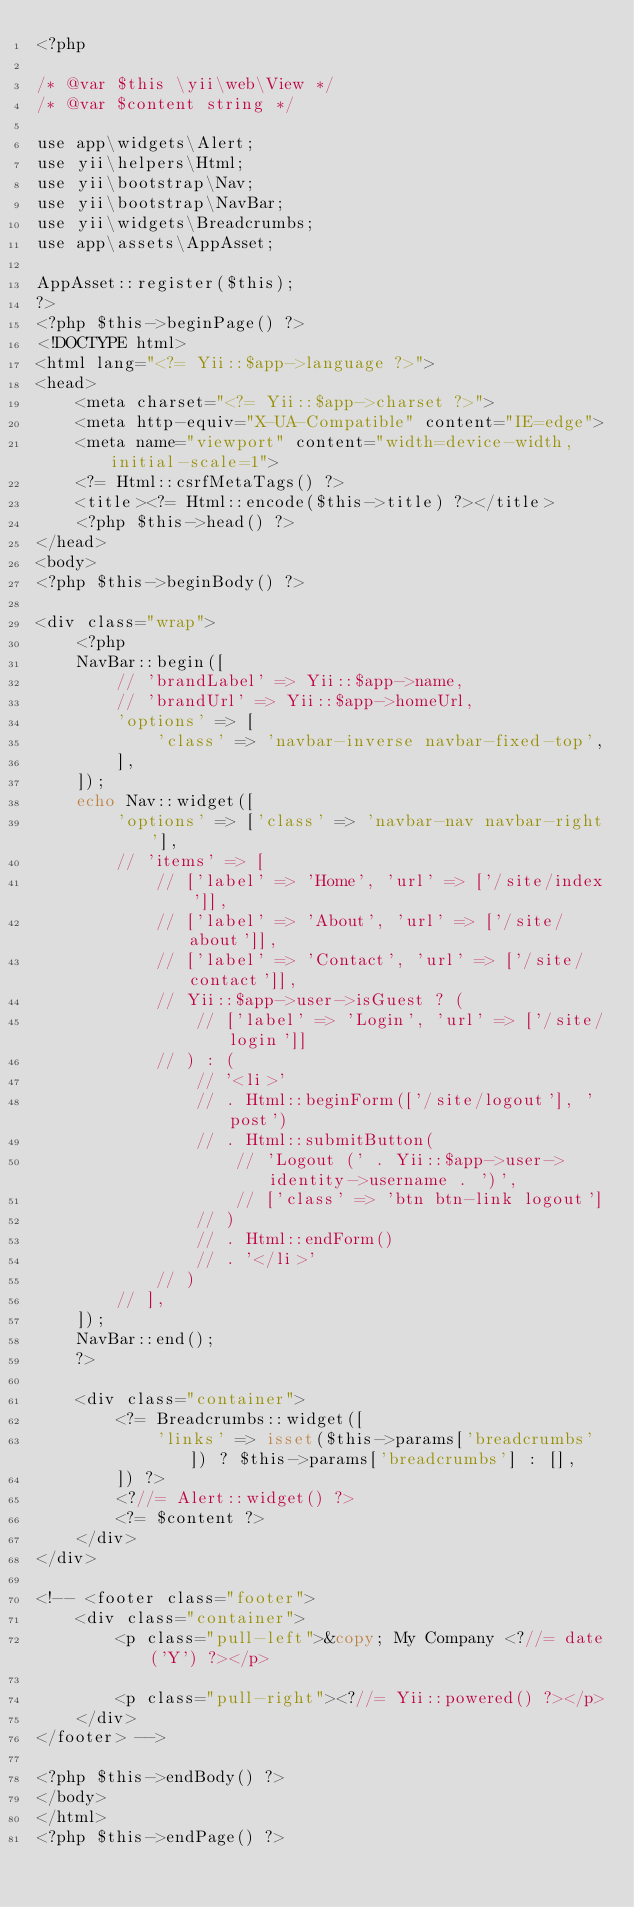Convert code to text. <code><loc_0><loc_0><loc_500><loc_500><_PHP_><?php

/* @var $this \yii\web\View */
/* @var $content string */

use app\widgets\Alert;
use yii\helpers\Html;
use yii\bootstrap\Nav;
use yii\bootstrap\NavBar;
use yii\widgets\Breadcrumbs;
use app\assets\AppAsset;

AppAsset::register($this);
?>
<?php $this->beginPage() ?>
<!DOCTYPE html>
<html lang="<?= Yii::$app->language ?>">
<head>
    <meta charset="<?= Yii::$app->charset ?>">
    <meta http-equiv="X-UA-Compatible" content="IE=edge">
    <meta name="viewport" content="width=device-width, initial-scale=1">
    <?= Html::csrfMetaTags() ?>
    <title><?= Html::encode($this->title) ?></title>
    <?php $this->head() ?>
</head>
<body>
<?php $this->beginBody() ?>

<div class="wrap">
    <?php
    NavBar::begin([
        // 'brandLabel' => Yii::$app->name,
        // 'brandUrl' => Yii::$app->homeUrl,
        'options' => [
            'class' => 'navbar-inverse navbar-fixed-top',
        ],
    ]);
    echo Nav::widget([
        'options' => ['class' => 'navbar-nav navbar-right'],
        // 'items' => [
            // ['label' => 'Home', 'url' => ['/site/index']],
            // ['label' => 'About', 'url' => ['/site/about']],
            // ['label' => 'Contact', 'url' => ['/site/contact']],
            // Yii::$app->user->isGuest ? (
                // ['label' => 'Login', 'url' => ['/site/login']]
            // ) : (
                // '<li>'
                // . Html::beginForm(['/site/logout'], 'post')
                // . Html::submitButton(
                    // 'Logout (' . Yii::$app->user->identity->username . ')',
                    // ['class' => 'btn btn-link logout']
                // )
                // . Html::endForm()
                // . '</li>'
            // )
        // ],
    ]);
    NavBar::end();
    ?>

    <div class="container">
        <?= Breadcrumbs::widget([
            'links' => isset($this->params['breadcrumbs']) ? $this->params['breadcrumbs'] : [],
        ]) ?>
        <?//= Alert::widget() ?>
        <?= $content ?>
    </div>
</div>

<!-- <footer class="footer">
    <div class="container">
        <p class="pull-left">&copy; My Company <?//= date('Y') ?></p>

        <p class="pull-right"><?//= Yii::powered() ?></p>
    </div>
</footer> -->

<?php $this->endBody() ?>
</body>
</html>
<?php $this->endPage() ?>
</code> 